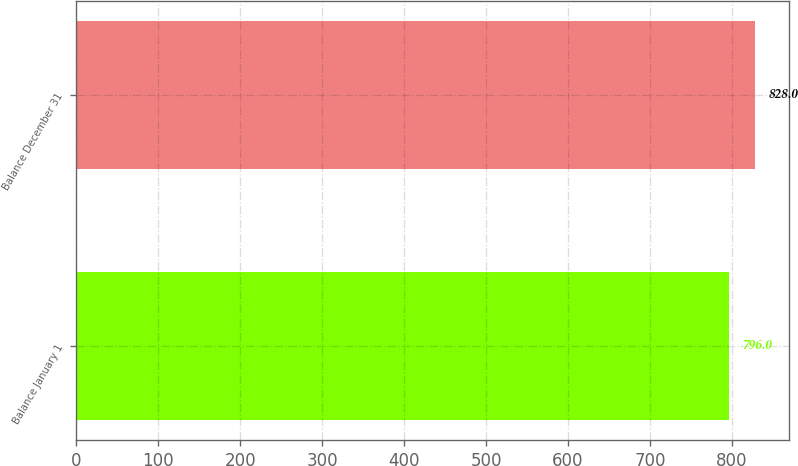Convert chart. <chart><loc_0><loc_0><loc_500><loc_500><bar_chart><fcel>Balance January 1<fcel>Balance December 31<nl><fcel>796<fcel>828<nl></chart> 